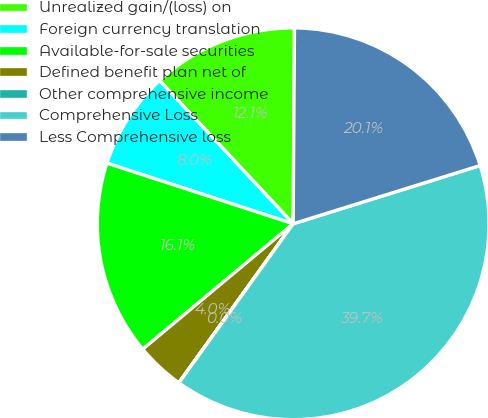<chart> <loc_0><loc_0><loc_500><loc_500><pie_chart><fcel>Unrealized gain/(loss) on<fcel>Foreign currency translation<fcel>Available-for-sale securities<fcel>Defined benefit plan net of<fcel>Other comprehensive income<fcel>Comprehensive Loss<fcel>Less Comprehensive loss<nl><fcel>12.06%<fcel>8.04%<fcel>16.07%<fcel>4.02%<fcel>0.01%<fcel>39.72%<fcel>20.09%<nl></chart> 